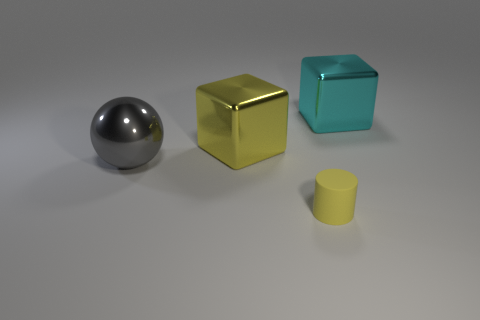Add 2 matte cylinders. How many objects exist? 6 Subtract all cylinders. How many objects are left? 3 Subtract all large cyan objects. Subtract all gray shiny spheres. How many objects are left? 2 Add 4 cyan metal objects. How many cyan metal objects are left? 5 Add 1 red shiny cylinders. How many red shiny cylinders exist? 1 Subtract 0 green spheres. How many objects are left? 4 